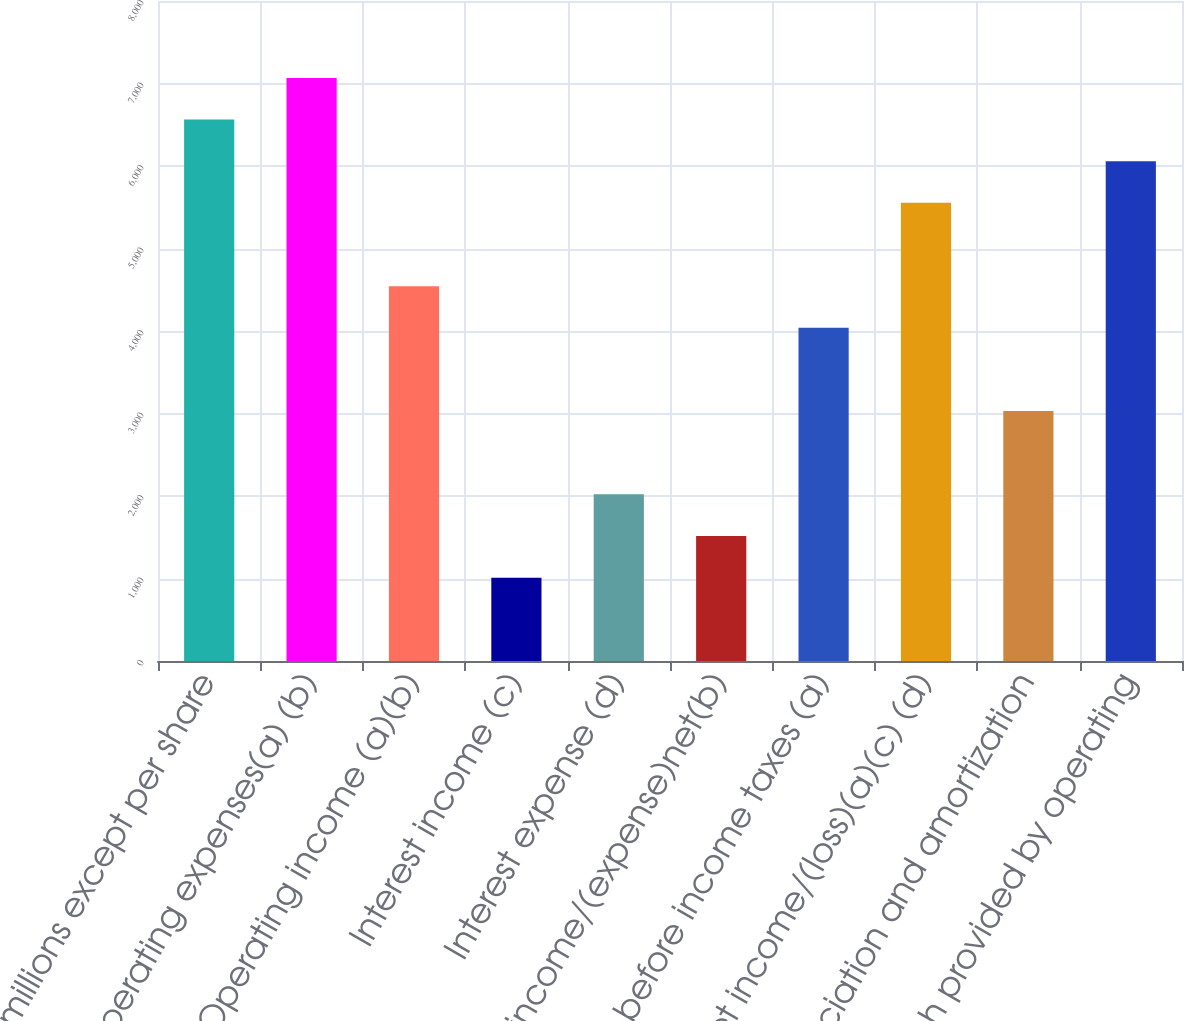Convert chart. <chart><loc_0><loc_0><loc_500><loc_500><bar_chart><fcel>(in millions except per share<fcel>Operating expenses(a) (b)<fcel>Operating income (a)(b)<fcel>Interest income (c)<fcel>Interest expense (d)<fcel>Other income/(expense)net(b)<fcel>Income before income taxes (a)<fcel>Net income/(loss)(a)(c) (d)<fcel>Depreciation and amortization<fcel>Net cash provided by operating<nl><fcel>6562.84<fcel>7067.62<fcel>4543.72<fcel>1010.26<fcel>2019.82<fcel>1515.04<fcel>4038.94<fcel>5553.28<fcel>3029.38<fcel>6058.06<nl></chart> 